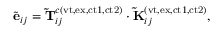<formula> <loc_0><loc_0><loc_500><loc_500>\tilde { e } _ { i j } = \widetilde { T } _ { i j } ^ { c ( v t , e x , c t 1 , c t 2 ) } \cdot \widetilde { K } _ { i j } ^ { ( v t , e x , c t 1 , c t 2 ) } ,</formula> 